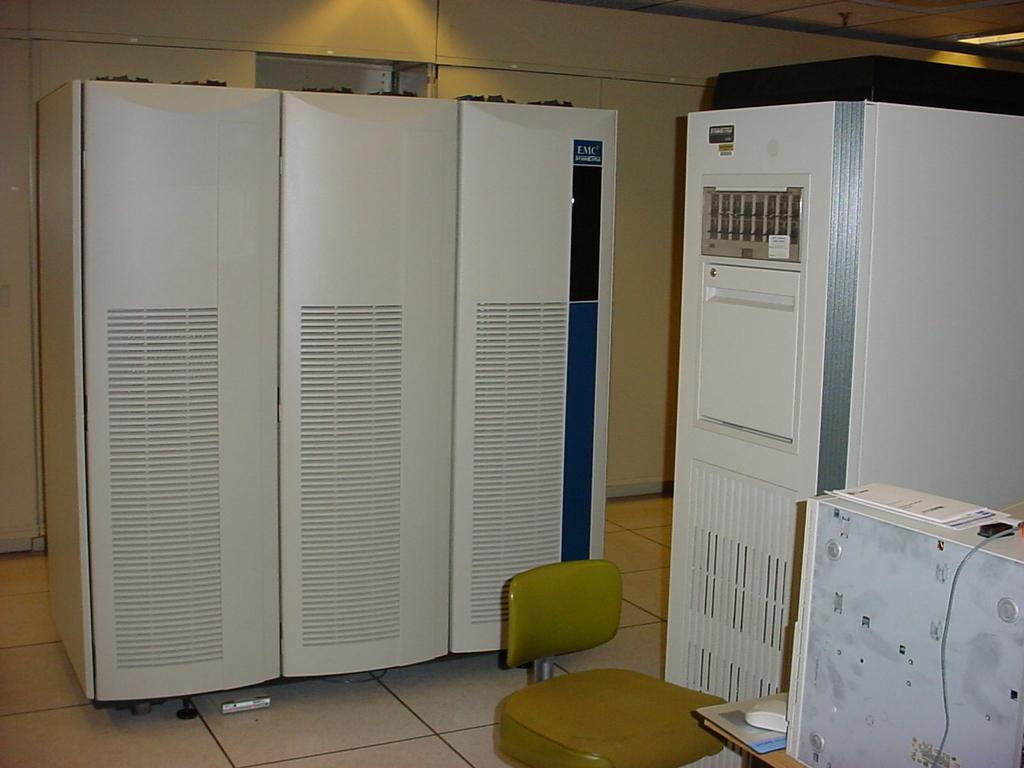What electronic device is located on the right side of the image? There is a CPU on the right side of the image. What input device is present on the table? There is a mouse on the table. How are the table, chair, and cabins arranged in the image? The table, chair, and cabins are beside each other. What can be seen in the background of the image? There are lights in the background of the image. How does the car move through the wax in the image? There is no car or wax present in the image; it features a CPU, a mouse, and furniture. 